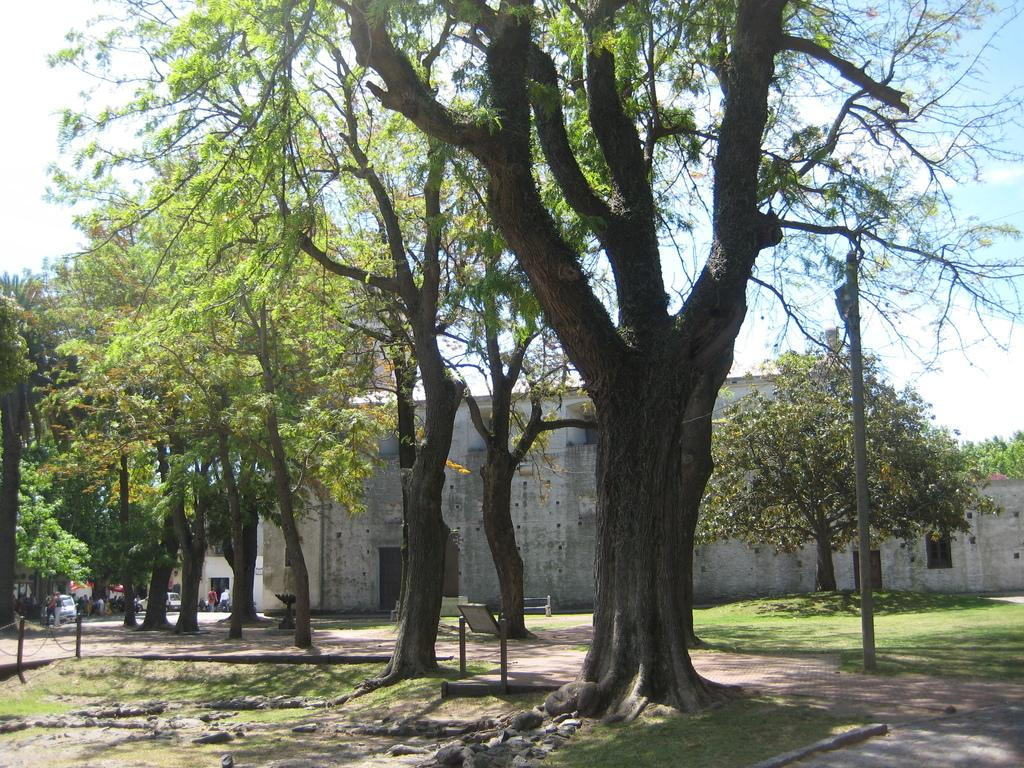What type of vegetation can be seen in the image? There are trees in the image. What structure is located near the trees? There is a building beside the trees. What else can be seen in the image besides trees and a building? There are vehicles in the image. Where are the people located in the image? These people are located in the left corner of the image. What type of pancake is being served to the people in the image? There is no pancake in the image, so it is not possible to answer that question. 